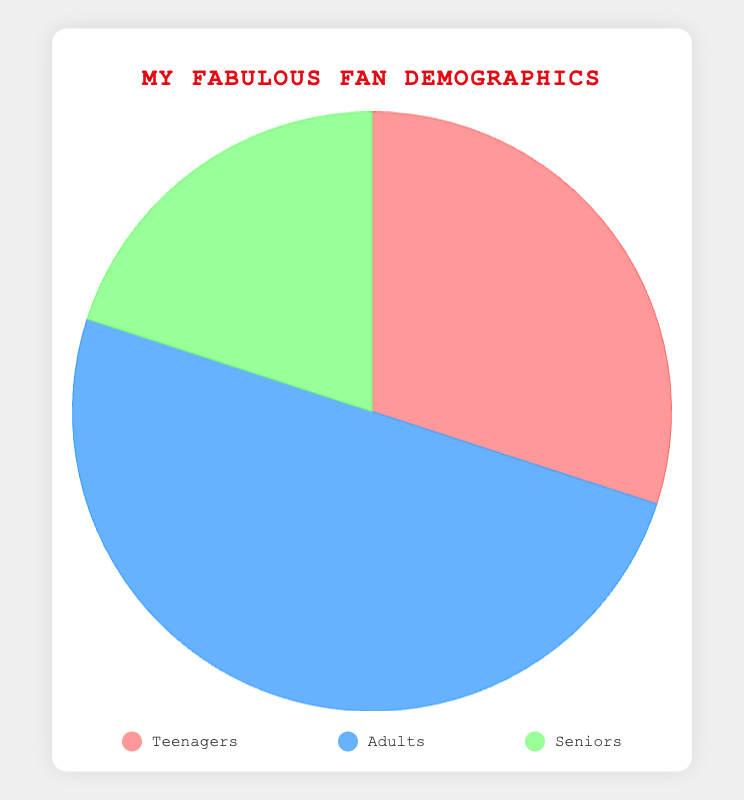What percentage of my fans are adults? Referring to the chart, the "Adults" segment is indicated by the blue color and is labeled with its percentage share.
Answer: 50% Which age group makes up the smallest portion of my fan base? By examining the pie chart, the smallest section is the "Seniors" segment, colored green, which constitutes 20% of the total.
Answer: Seniors How much larger is the adult fan base compared to the teenage fan base? To find the difference, subtract the percentage of teenagers (30%) from the percentage of adults (50%): 50% - 30% = 20%.
Answer: Adults are 20% larger What is the combined percentage for teenagers and seniors? Add the percentages for teenagers (30%) and seniors (20%): 30% + 20% = 50%.
Answer: 50% Which color represents the teenage fan base, and what is their percentage? The chart shows that the teenage segment is colored red and makes up 30% of the fan base.
Answer: Red, 30% If I had 2000 fans, how many would be seniors? Calculate 20% of 2000 by multiplying 2000 by 0.20: 2000 * 0.20 = 400.
Answer: 400 How do the percentages of adult fans and senior fans compare? The percentage of adult fans (50%) is more than double that of senior fans (20%).
Answer: Adults are more than double Which age group makes up half of the total fans? The pie chart indicates that the "Adults" section is exactly 50% of the total fan base.
Answer: Adults What is the total percentage represented by the chart? By summing the percentages of all age groups (Teenagers 30%, Adults 50%, Seniors 20%), we get 100%.
Answer: 100% Are there more teenagers or adults among my fans? The pie chart shows that adults (50%) outnumber teenagers (30%) among the fans.
Answer: Adults 